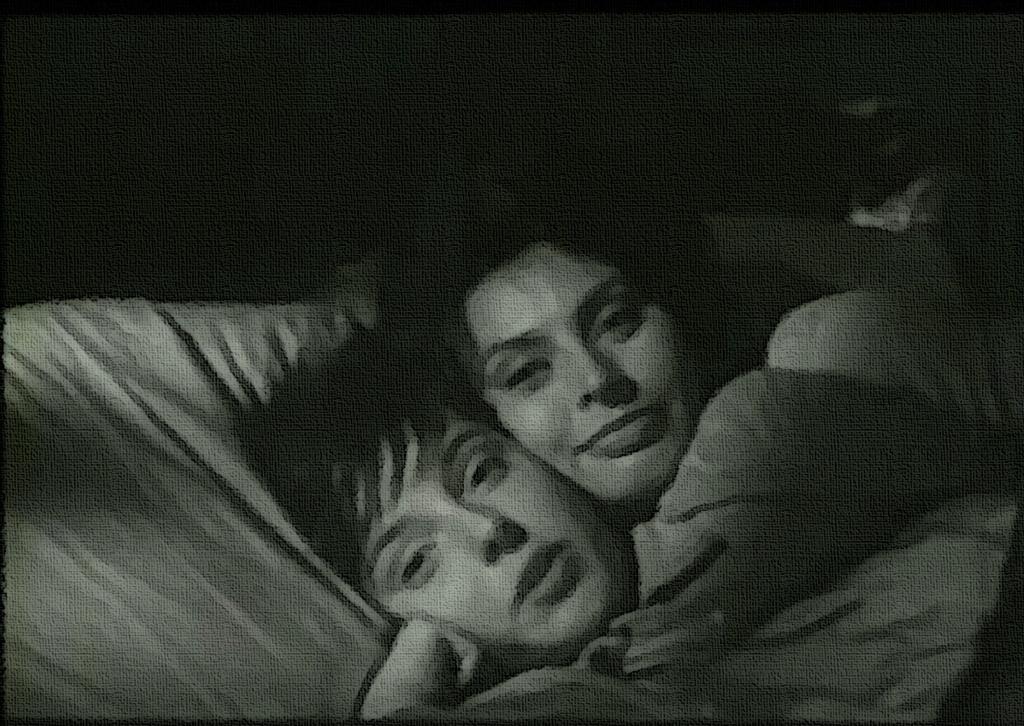Please provide a concise description of this image. This is black and white image, we can see a few people lying on the bed, and we can see the dark background. 